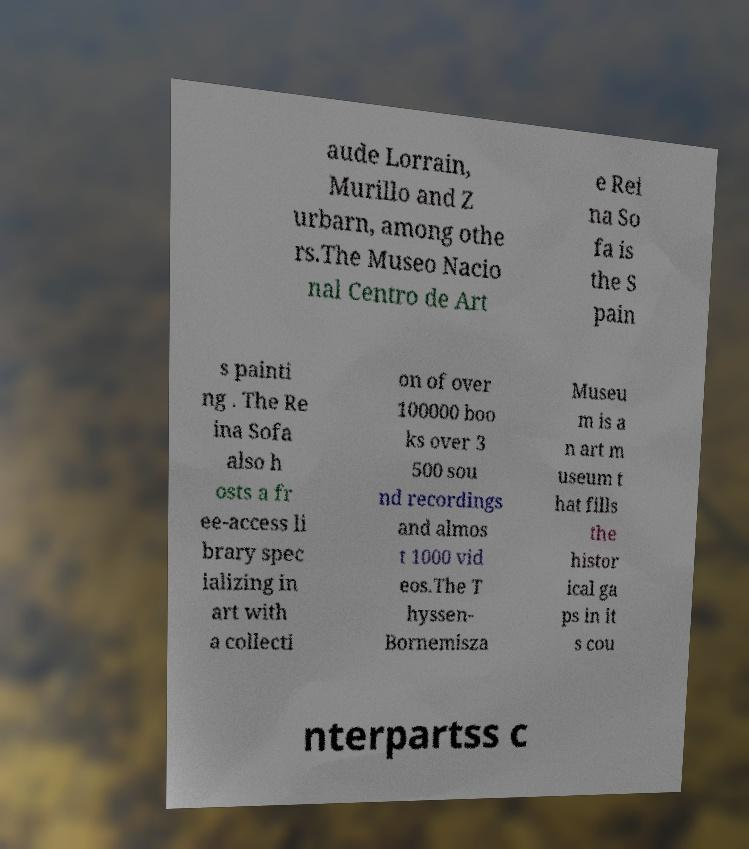Can you accurately transcribe the text from the provided image for me? aude Lorrain, Murillo and Z urbarn, among othe rs.The Museo Nacio nal Centro de Art e Rei na So fa is the S pain s painti ng . The Re ina Sofa also h osts a fr ee-access li brary spec ializing in art with a collecti on of over 100000 boo ks over 3 500 sou nd recordings and almos t 1000 vid eos.The T hyssen- Bornemisza Museu m is a n art m useum t hat fills the histor ical ga ps in it s cou nterpartss c 